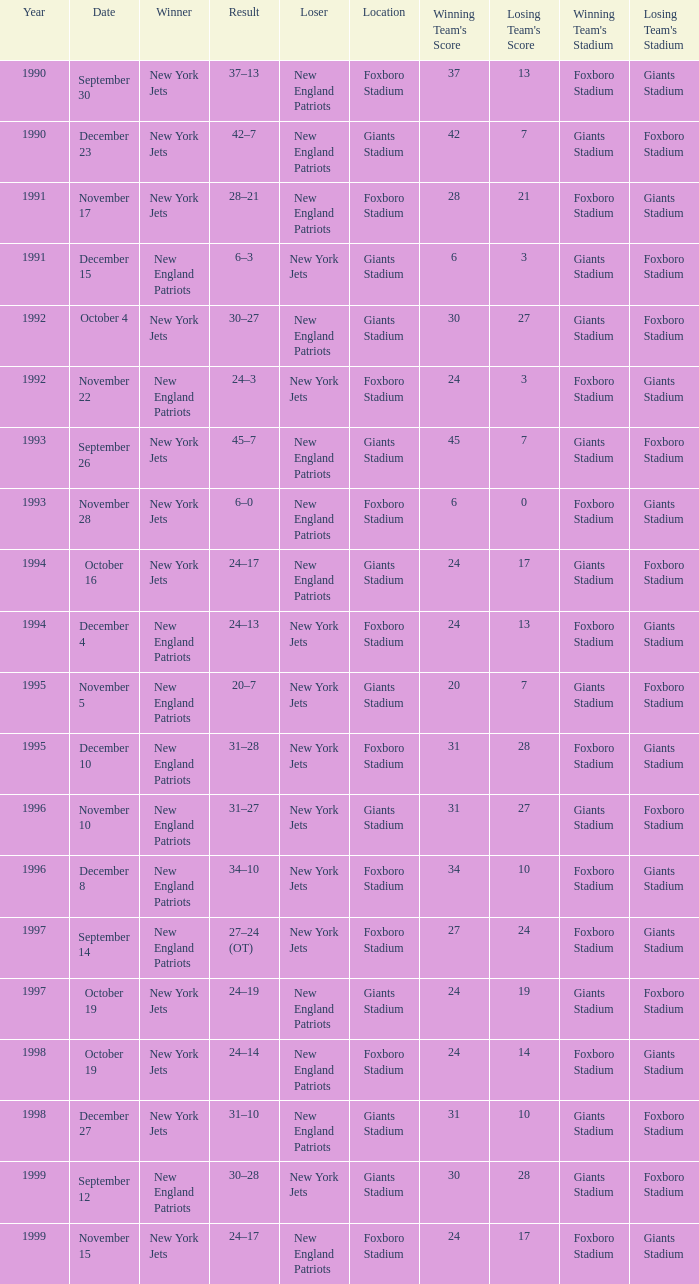What is the year when the Winner was the new york jets, with a Result of 24–17, played at giants stadium? 1994.0. 